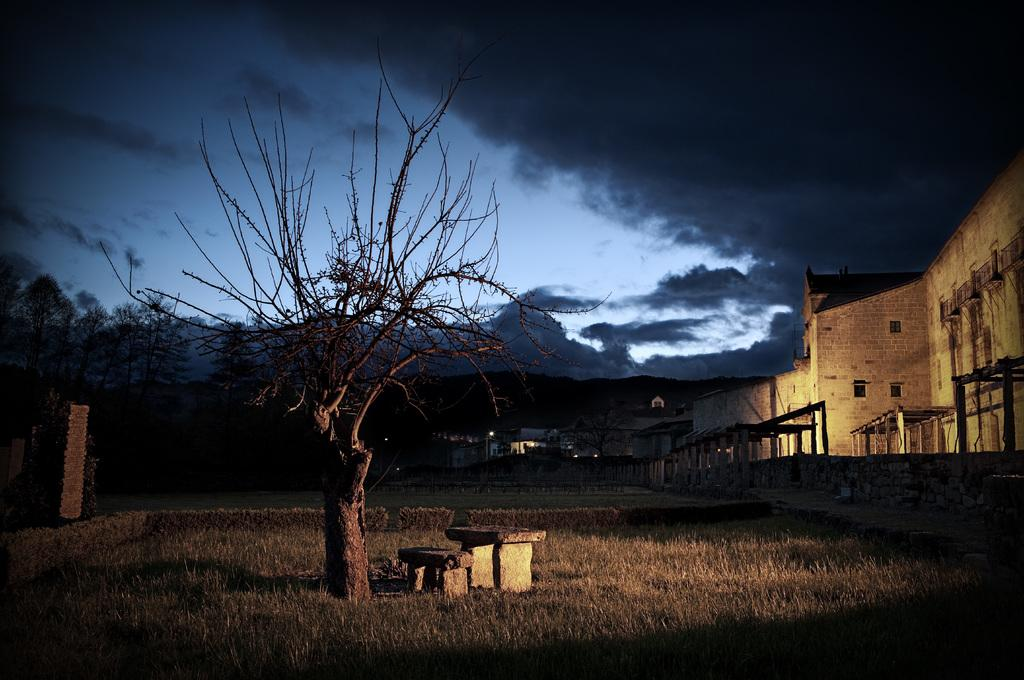What type of vegetation is present in the foreground of the image? There are trees and grass in the foreground of the image. What type of structures can be seen in the background of the image? There are houses in the background of the image. What other natural elements are visible in the background of the image? There are trees and mountains in the background of the image. What is visible at the top of the image? The sky is visible at the top of the image. Where is the meeting taking place in the image? There is no meeting present in the image; it features a landscape with trees, grass, houses, mountains, and the sky. What type of war is depicted in the image? There is no war depicted in the image; it is a peaceful landscape scene. 